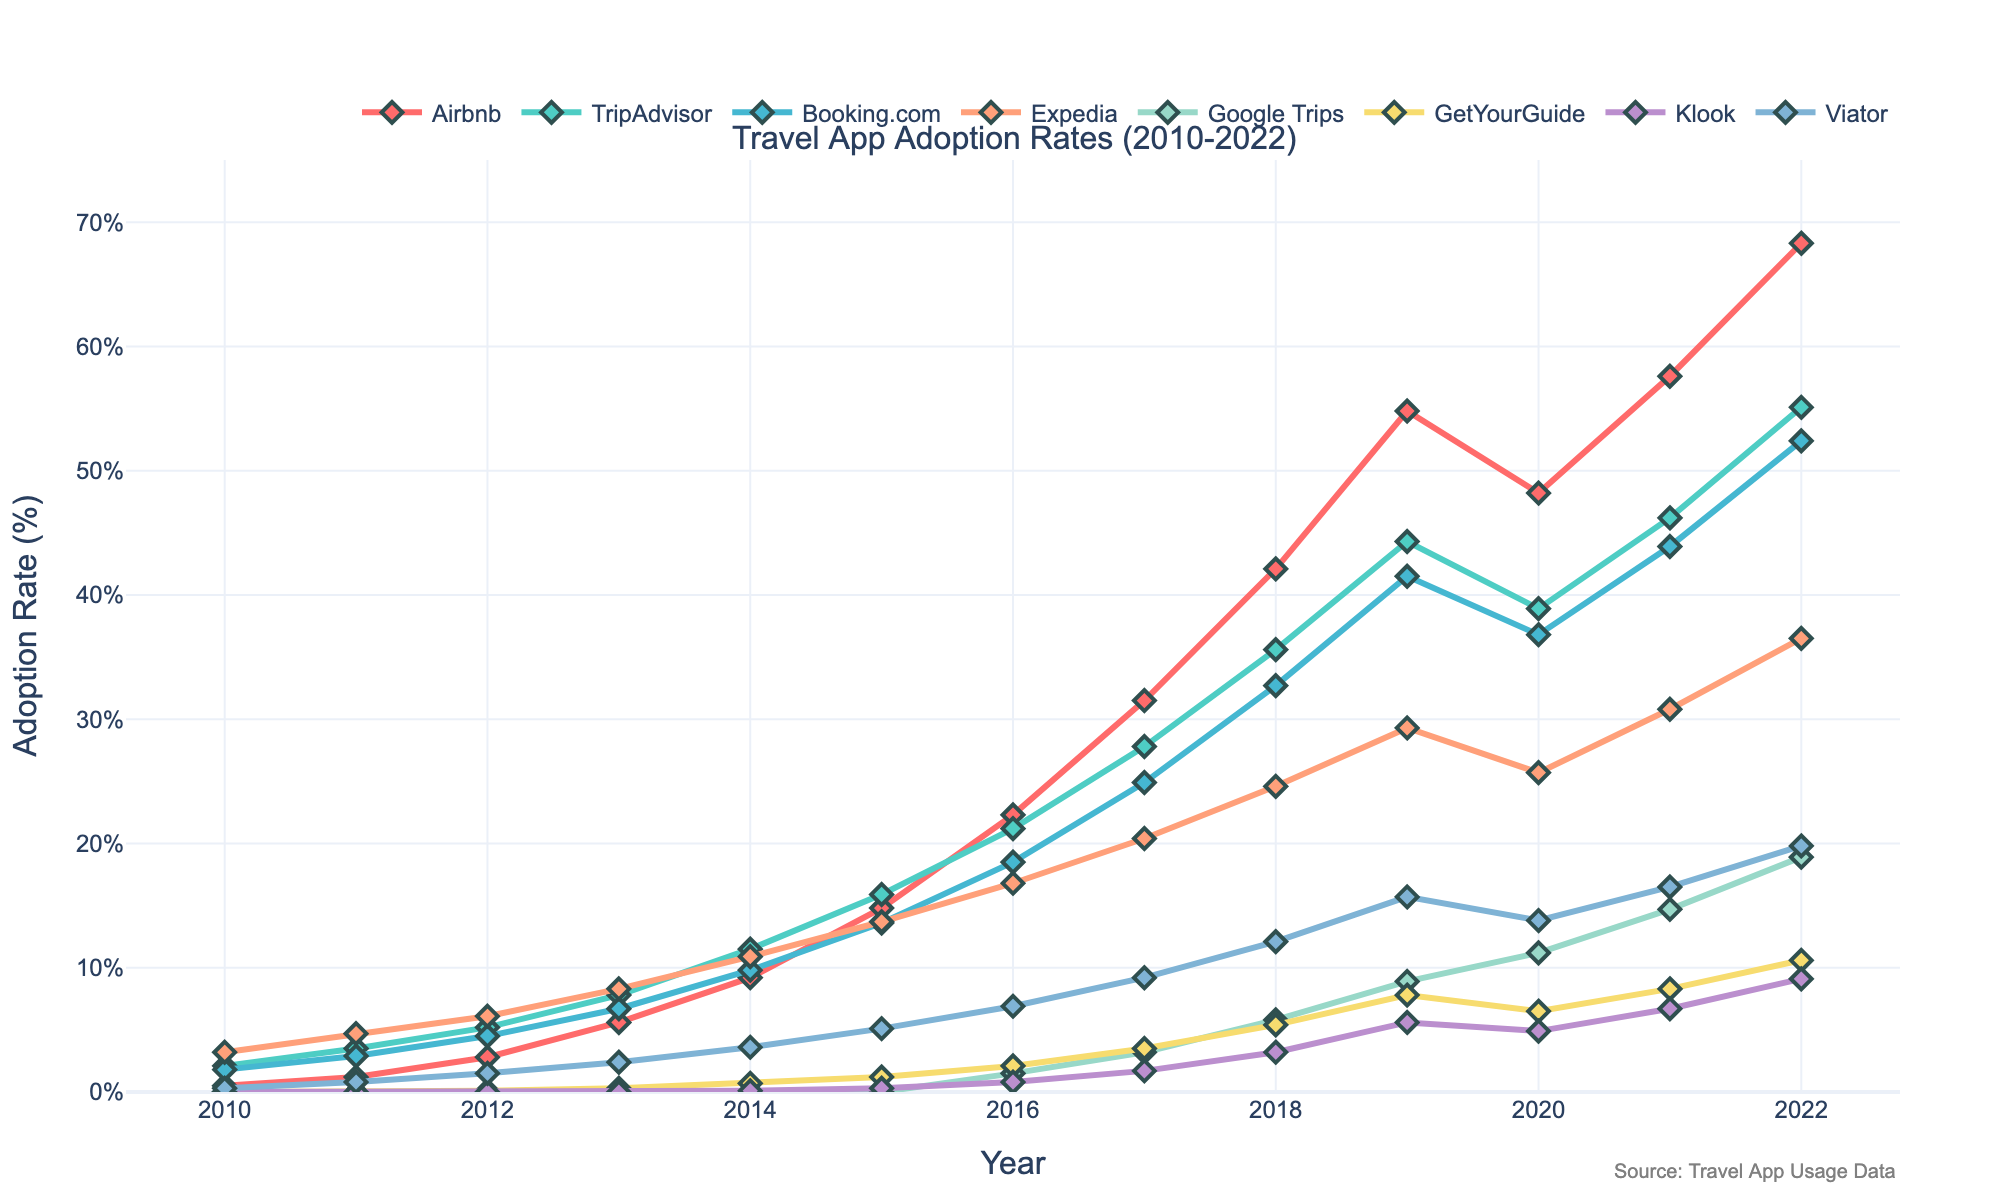What is the adoption rate of Airbnb in 2015? Look at the y-axis value for Airbnb in 2015
Answer: 14.8% Which app had the highest adoption rate in 2022? Compare the adoption rates of all apps in 2022
Answer: Airbnb Between 2010 and 2012, which app showed the steepest increase in adoption rate? Calculate the differences in adoption rates for each app between 2010 and 2012 and identify the largest difference: Airbnb (2.8-0.5 = 2.3), TripAdvisor (5.2-2.1 = 3.1), Booking.com (4.5-1.8 = 2.7), Expedia (6.1-3.2 = 2.9), Google Trips (0-0 = 0), GetYourGuide (0.1-0 = 0.1), Klook (0-0 = 0), Viator (1.5-0.3 = 1.2)
Answer: TripAdvisor What is the overall trend for Google Trips adoption rates from 2016 to 2022? Track and compare the y-values for Google Trips between 2016 and 2022 to see if they generally increase, decrease, or stay flat. The data points increase from 1.5 in 2016 to 18.9 in 2022
Answer: Increasing trend Which app had the lowest adoption rate in 2018, and what was it? Identify the y-values in 2018 for all apps and find the smallest value: Airbnb (42.1), TripAdvisor (35.6), Booking.com (32.7), Expedia (24.6), Google Trips (5.8), GetYourGuide (5.4), Klook (3.2), Viator (12.1)
Answer: Klook, 3.2% Has the adoption rate for Viator consistently increased every year? Check the y-values for Viator across all years to see if each subsequent year is higher than the previous: (2010: 0.3), (2011: 0.8), (2012: 1.5), (2013: 2.4), (2014: 3.6), (2015: 5.1), (2016: 6.9), (2017: 9.2), (2018: 12.1), (2019: 15.7), (2020: 13.8), (2021: 16.5), (2022: 19.8). It decreased from 2019 to 2020
Answer: No From 2019 to 2020, which app experienced the largest decrease in adoption rate? Calculate the differences in adoption rates for each app from 2019 to 2020 and identify the largest negative difference: Airbnb (54.8 to 48.2 = -6.6), TripAdvisor (44.3 to 38.9 = -5.4), Booking.com (41.5 to 36.8 = -4.7), Expedia (29.3 to 25.7 = -3.6), Google Trips (8.9 to 11.2 = +2.3), GetYourGuide (7.8 to 6.5 = -1.3), Klook (5.6 to 4.9 = -0.7), Viator (15.7 to 13.8 = -1.9)
Answer: Airbnb Compare the adoption rates of Google Trips and GetYourGuide in 2022. Which one is higher and by how much? Find the adoption rates for Google Trips (18.9) and GetYourGuide (10.6) in 2022 and calculate the difference: 18.9 - 10.6 = 8.3
Answer: Google Trips, 8.3% What visual characteristic indicates that TripAdvisor had strong adoption rates in earlier years? Look at the color and height of the line representing TripAdvisor in the earlier years; it starts higher and increases quickly
Answer: Early rapid growth 